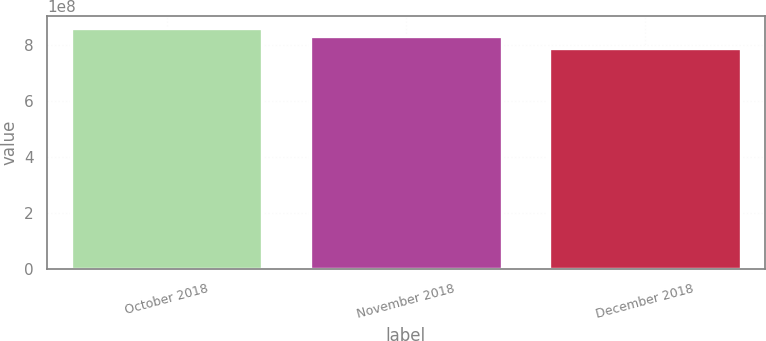Convert chart to OTSL. <chart><loc_0><loc_0><loc_500><loc_500><bar_chart><fcel>October 2018<fcel>November 2018<fcel>December 2018<nl><fcel>8.59039e+08<fcel>8.31428e+08<fcel>7.87614e+08<nl></chart> 